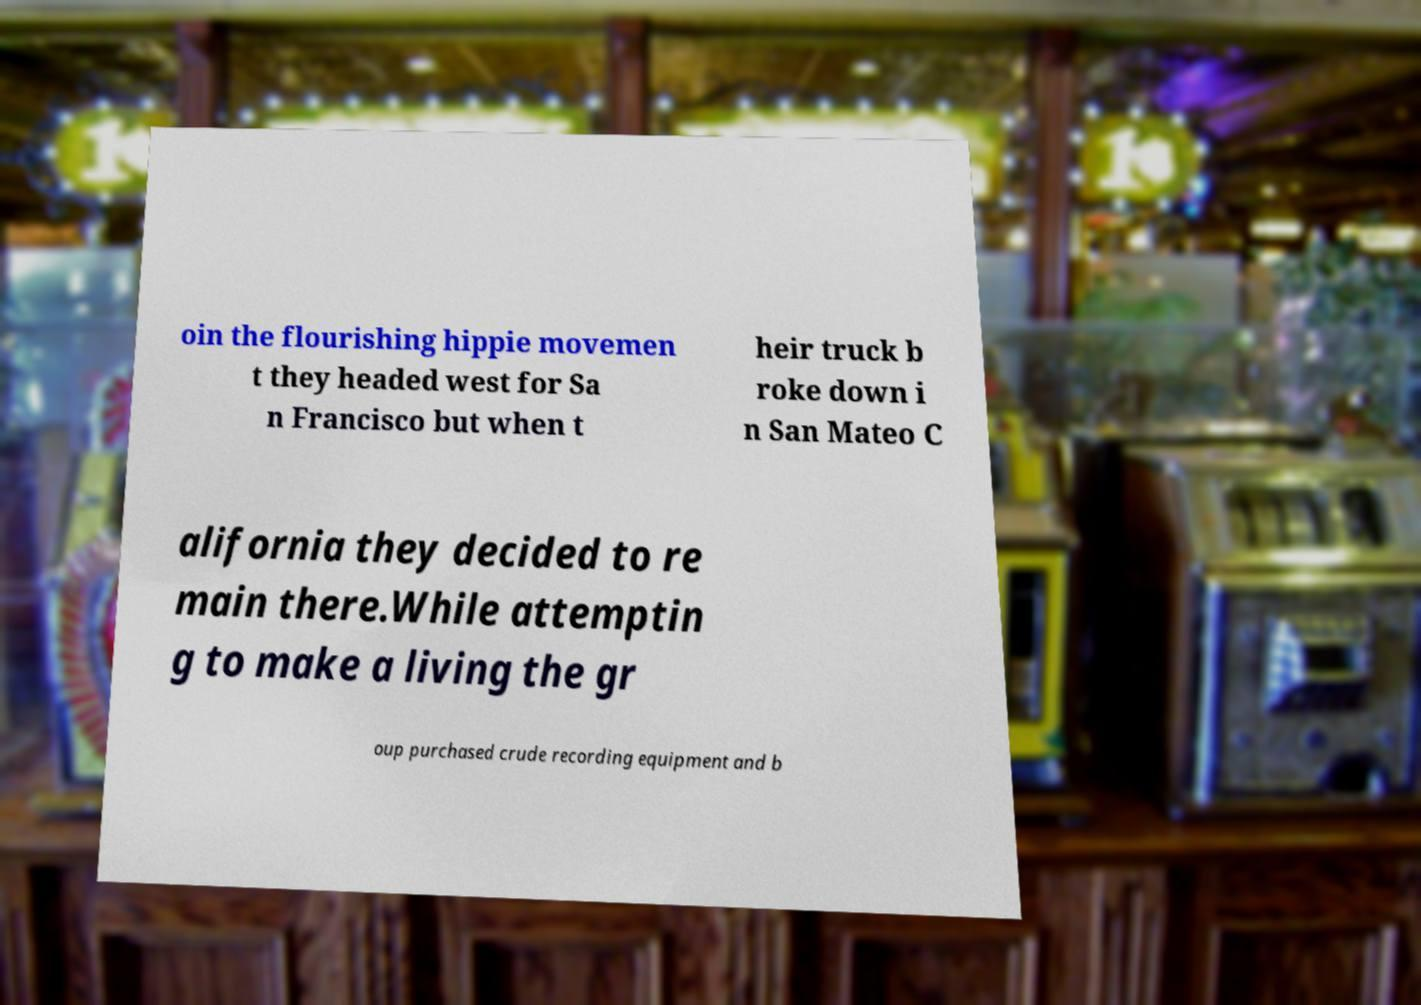Please read and relay the text visible in this image. What does it say? oin the flourishing hippie movemen t they headed west for Sa n Francisco but when t heir truck b roke down i n San Mateo C alifornia they decided to re main there.While attemptin g to make a living the gr oup purchased crude recording equipment and b 